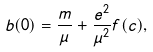<formula> <loc_0><loc_0><loc_500><loc_500>b ( 0 ) = \frac { m } { \mu } + \frac { e ^ { 2 } } { \mu ^ { 2 } } f ( c ) ,</formula> 